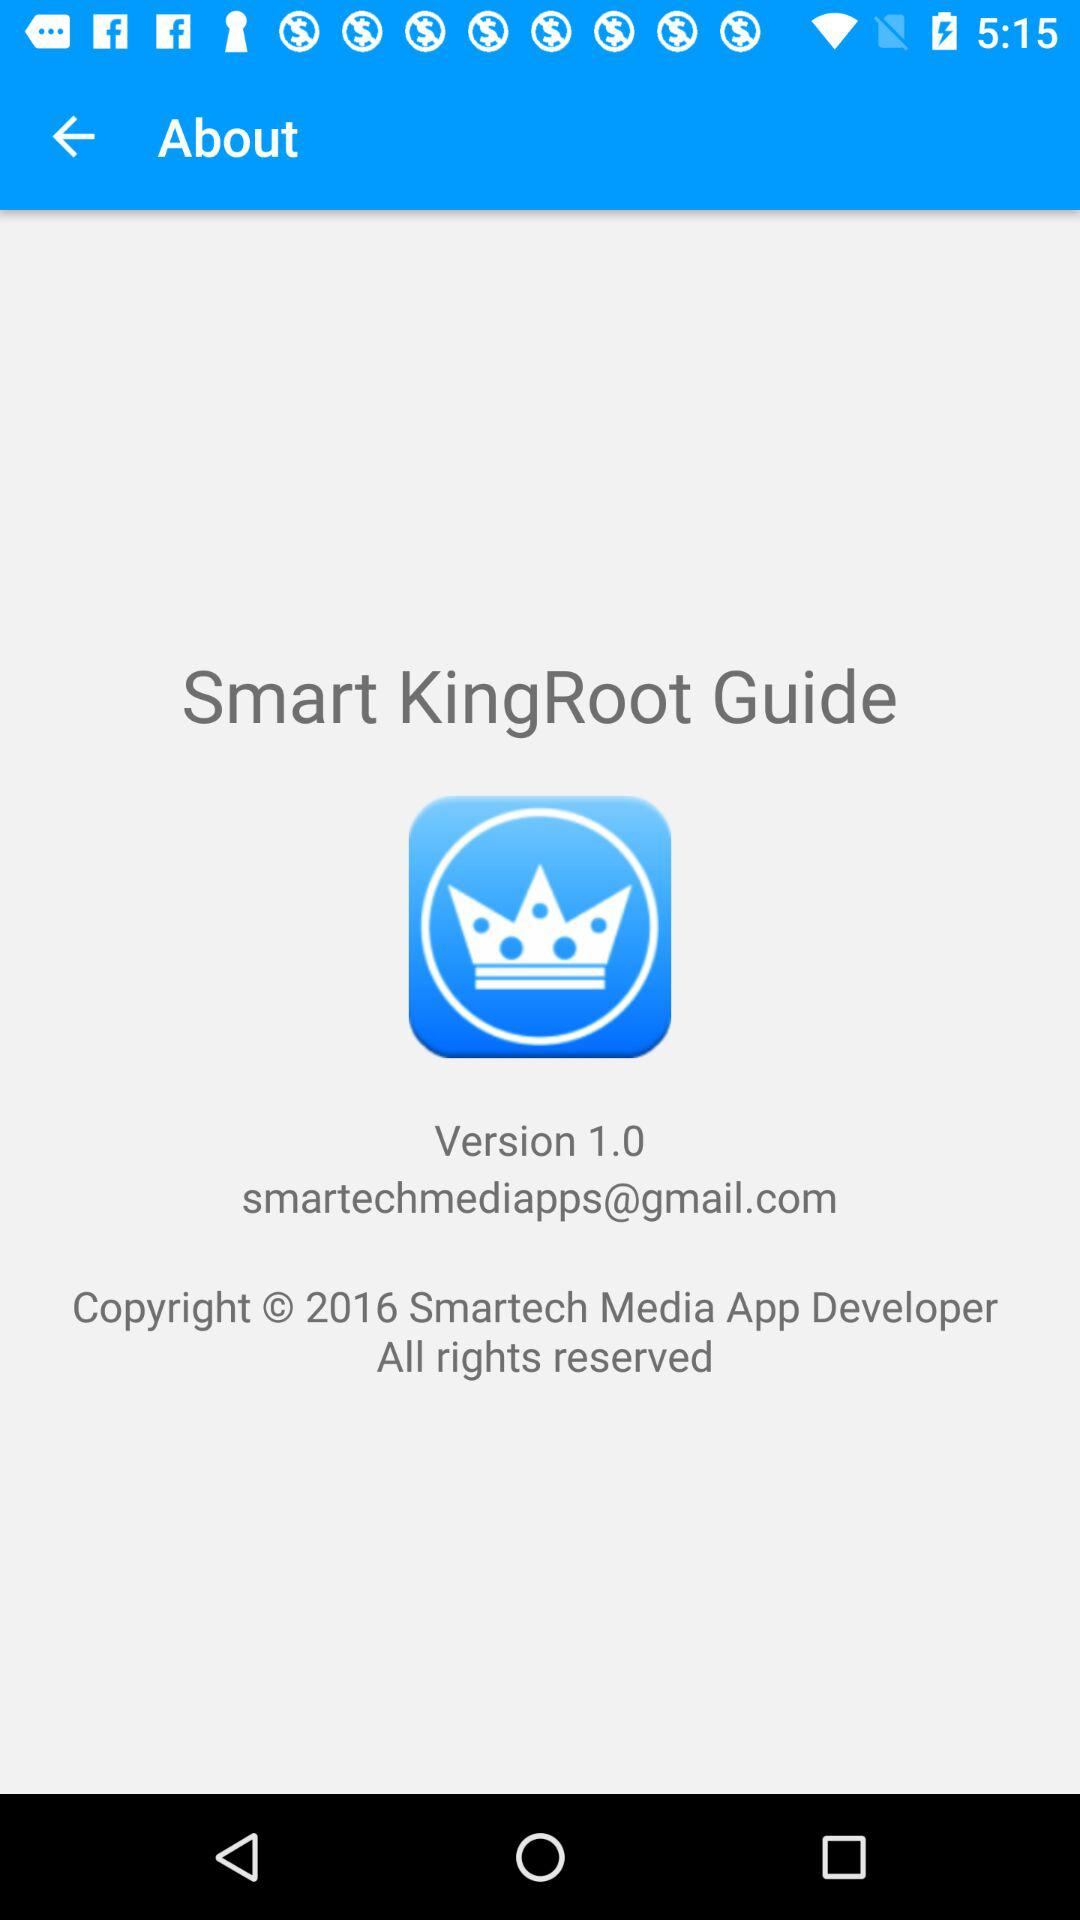What is the version of the application being used? The version of the application being used is 1.0. 